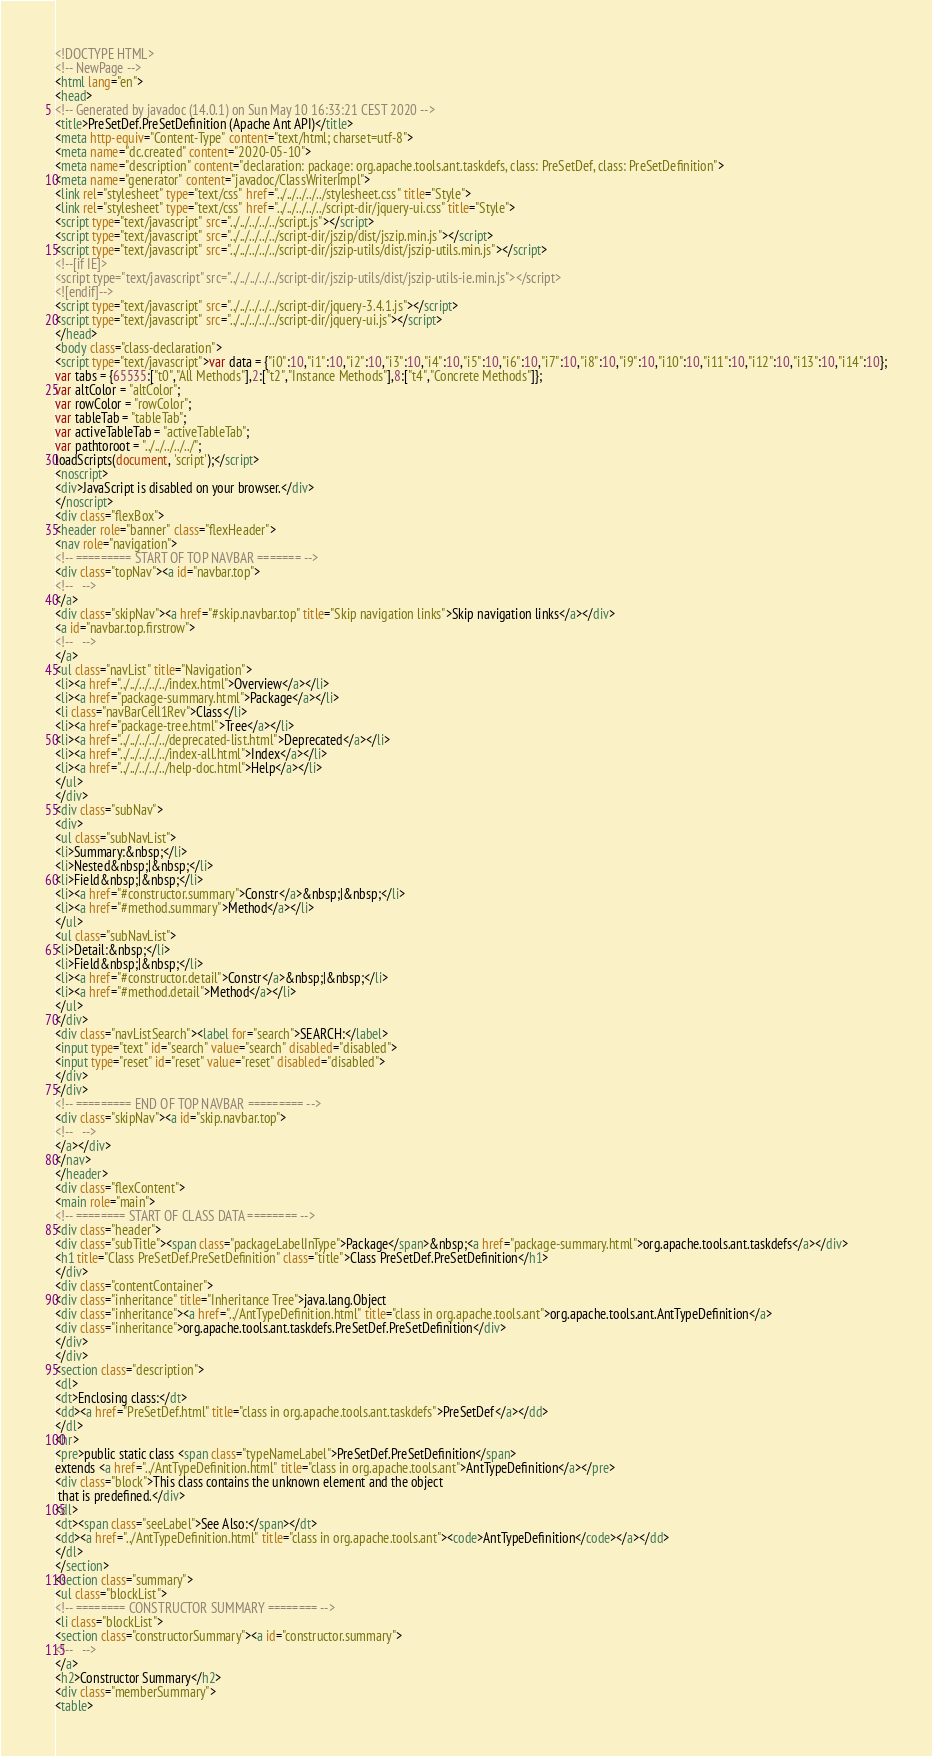Convert code to text. <code><loc_0><loc_0><loc_500><loc_500><_HTML_><!DOCTYPE HTML>
<!-- NewPage -->
<html lang="en">
<head>
<!-- Generated by javadoc (14.0.1) on Sun May 10 16:33:21 CEST 2020 -->
<title>PreSetDef.PreSetDefinition (Apache Ant API)</title>
<meta http-equiv="Content-Type" content="text/html; charset=utf-8">
<meta name="dc.created" content="2020-05-10">
<meta name="description" content="declaration: package: org.apache.tools.ant.taskdefs, class: PreSetDef, class: PreSetDefinition">
<meta name="generator" content="javadoc/ClassWriterImpl">
<link rel="stylesheet" type="text/css" href="../../../../../stylesheet.css" title="Style">
<link rel="stylesheet" type="text/css" href="../../../../../script-dir/jquery-ui.css" title="Style">
<script type="text/javascript" src="../../../../../script.js"></script>
<script type="text/javascript" src="../../../../../script-dir/jszip/dist/jszip.min.js"></script>
<script type="text/javascript" src="../../../../../script-dir/jszip-utils/dist/jszip-utils.min.js"></script>
<!--[if IE]>
<script type="text/javascript" src="../../../../../script-dir/jszip-utils/dist/jszip-utils-ie.min.js"></script>
<![endif]-->
<script type="text/javascript" src="../../../../../script-dir/jquery-3.4.1.js"></script>
<script type="text/javascript" src="../../../../../script-dir/jquery-ui.js"></script>
</head>
<body class="class-declaration">
<script type="text/javascript">var data = {"i0":10,"i1":10,"i2":10,"i3":10,"i4":10,"i5":10,"i6":10,"i7":10,"i8":10,"i9":10,"i10":10,"i11":10,"i12":10,"i13":10,"i14":10};
var tabs = {65535:["t0","All Methods"],2:["t2","Instance Methods"],8:["t4","Concrete Methods"]};
var altColor = "altColor";
var rowColor = "rowColor";
var tableTab = "tableTab";
var activeTableTab = "activeTableTab";
var pathtoroot = "../../../../../";
loadScripts(document, 'script');</script>
<noscript>
<div>JavaScript is disabled on your browser.</div>
</noscript>
<div class="flexBox">
<header role="banner" class="flexHeader">
<nav role="navigation">
<!-- ========= START OF TOP NAVBAR ======= -->
<div class="topNav"><a id="navbar.top">
<!--   -->
</a>
<div class="skipNav"><a href="#skip.navbar.top" title="Skip navigation links">Skip navigation links</a></div>
<a id="navbar.top.firstrow">
<!--   -->
</a>
<ul class="navList" title="Navigation">
<li><a href="../../../../../index.html">Overview</a></li>
<li><a href="package-summary.html">Package</a></li>
<li class="navBarCell1Rev">Class</li>
<li><a href="package-tree.html">Tree</a></li>
<li><a href="../../../../../deprecated-list.html">Deprecated</a></li>
<li><a href="../../../../../index-all.html">Index</a></li>
<li><a href="../../../../../help-doc.html">Help</a></li>
</ul>
</div>
<div class="subNav">
<div>
<ul class="subNavList">
<li>Summary:&nbsp;</li>
<li>Nested&nbsp;|&nbsp;</li>
<li>Field&nbsp;|&nbsp;</li>
<li><a href="#constructor.summary">Constr</a>&nbsp;|&nbsp;</li>
<li><a href="#method.summary">Method</a></li>
</ul>
<ul class="subNavList">
<li>Detail:&nbsp;</li>
<li>Field&nbsp;|&nbsp;</li>
<li><a href="#constructor.detail">Constr</a>&nbsp;|&nbsp;</li>
<li><a href="#method.detail">Method</a></li>
</ul>
</div>
<div class="navListSearch"><label for="search">SEARCH:</label>
<input type="text" id="search" value="search" disabled="disabled">
<input type="reset" id="reset" value="reset" disabled="disabled">
</div>
</div>
<!-- ========= END OF TOP NAVBAR ========= -->
<div class="skipNav"><a id="skip.navbar.top">
<!--   -->
</a></div>
</nav>
</header>
<div class="flexContent">
<main role="main">
<!-- ======== START OF CLASS DATA ======== -->
<div class="header">
<div class="subTitle"><span class="packageLabelInType">Package</span>&nbsp;<a href="package-summary.html">org.apache.tools.ant.taskdefs</a></div>
<h1 title="Class PreSetDef.PreSetDefinition" class="title">Class PreSetDef.PreSetDefinition</h1>
</div>
<div class="contentContainer">
<div class="inheritance" title="Inheritance Tree">java.lang.Object
<div class="inheritance"><a href="../AntTypeDefinition.html" title="class in org.apache.tools.ant">org.apache.tools.ant.AntTypeDefinition</a>
<div class="inheritance">org.apache.tools.ant.taskdefs.PreSetDef.PreSetDefinition</div>
</div>
</div>
<section class="description">
<dl>
<dt>Enclosing class:</dt>
<dd><a href="PreSetDef.html" title="class in org.apache.tools.ant.taskdefs">PreSetDef</a></dd>
</dl>
<hr>
<pre>public static class <span class="typeNameLabel">PreSetDef.PreSetDefinition</span>
extends <a href="../AntTypeDefinition.html" title="class in org.apache.tools.ant">AntTypeDefinition</a></pre>
<div class="block">This class contains the unknown element and the object
 that is predefined.</div>
<dl>
<dt><span class="seeLabel">See Also:</span></dt>
<dd><a href="../AntTypeDefinition.html" title="class in org.apache.tools.ant"><code>AntTypeDefinition</code></a></dd>
</dl>
</section>
<section class="summary">
<ul class="blockList">
<!-- ======== CONSTRUCTOR SUMMARY ======== -->
<li class="blockList">
<section class="constructorSummary"><a id="constructor.summary">
<!--   -->
</a>
<h2>Constructor Summary</h2>
<div class="memberSummary">
<table></code> 